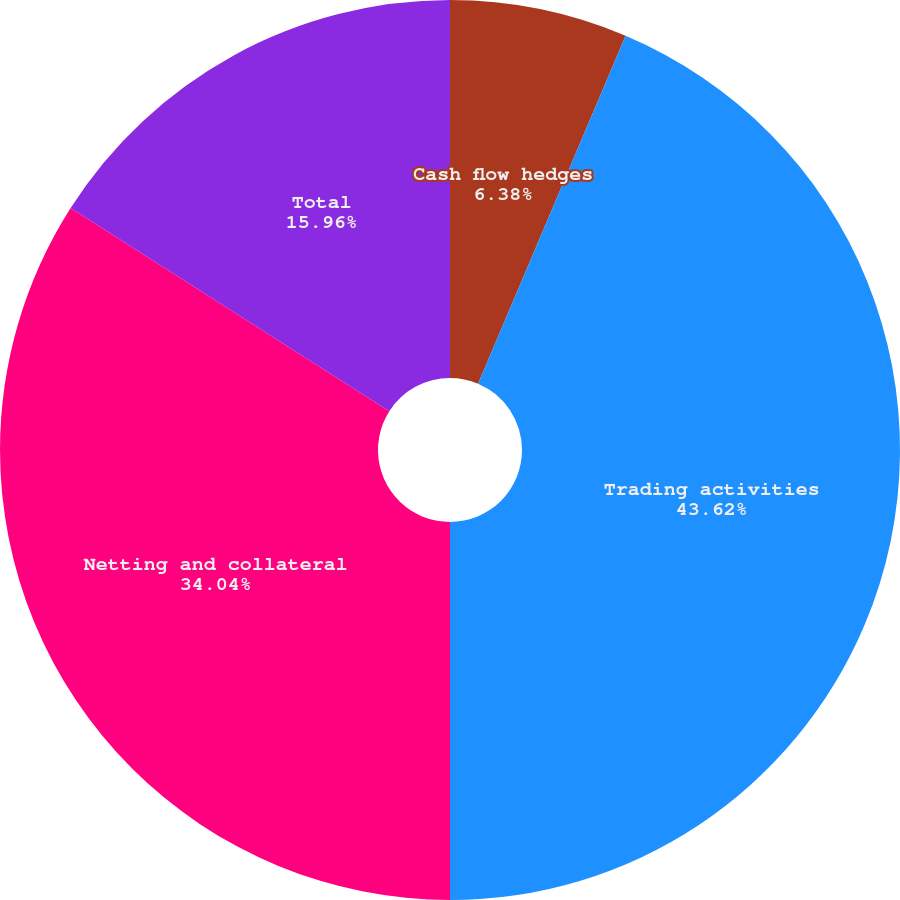Convert chart to OTSL. <chart><loc_0><loc_0><loc_500><loc_500><pie_chart><fcel>Cash flow hedges<fcel>Trading activities<fcel>Netting and collateral<fcel>Total<nl><fcel>6.38%<fcel>43.62%<fcel>34.04%<fcel>15.96%<nl></chart> 